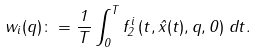Convert formula to latex. <formula><loc_0><loc_0><loc_500><loc_500>w _ { i } ( q ) \colon = \frac { 1 } { T } \int _ { 0 } ^ { T } f _ { 2 } ^ { i } \left ( t , \hat { x } ( t ) , q , 0 \right ) \, d t .</formula> 